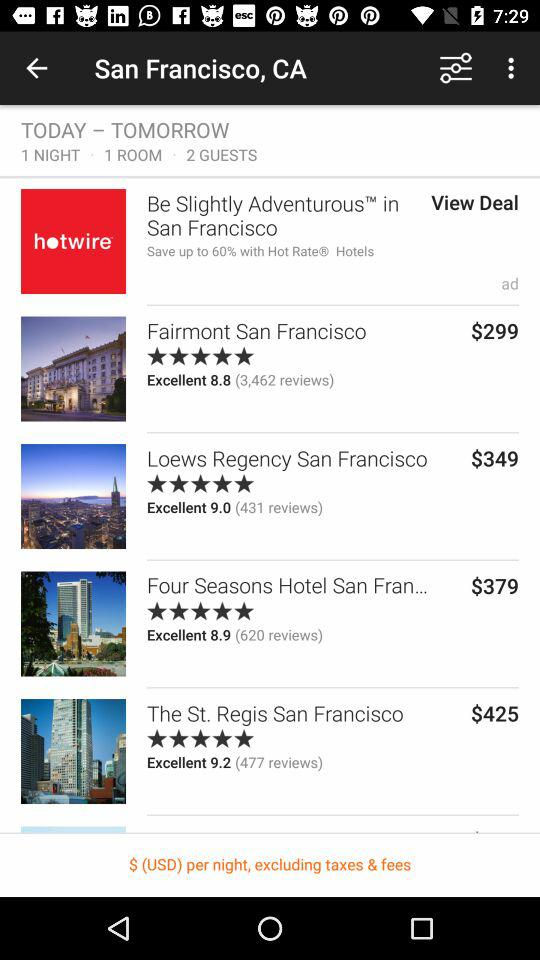What is the price for "The St. Regis San Francisco"? The price is $425. 